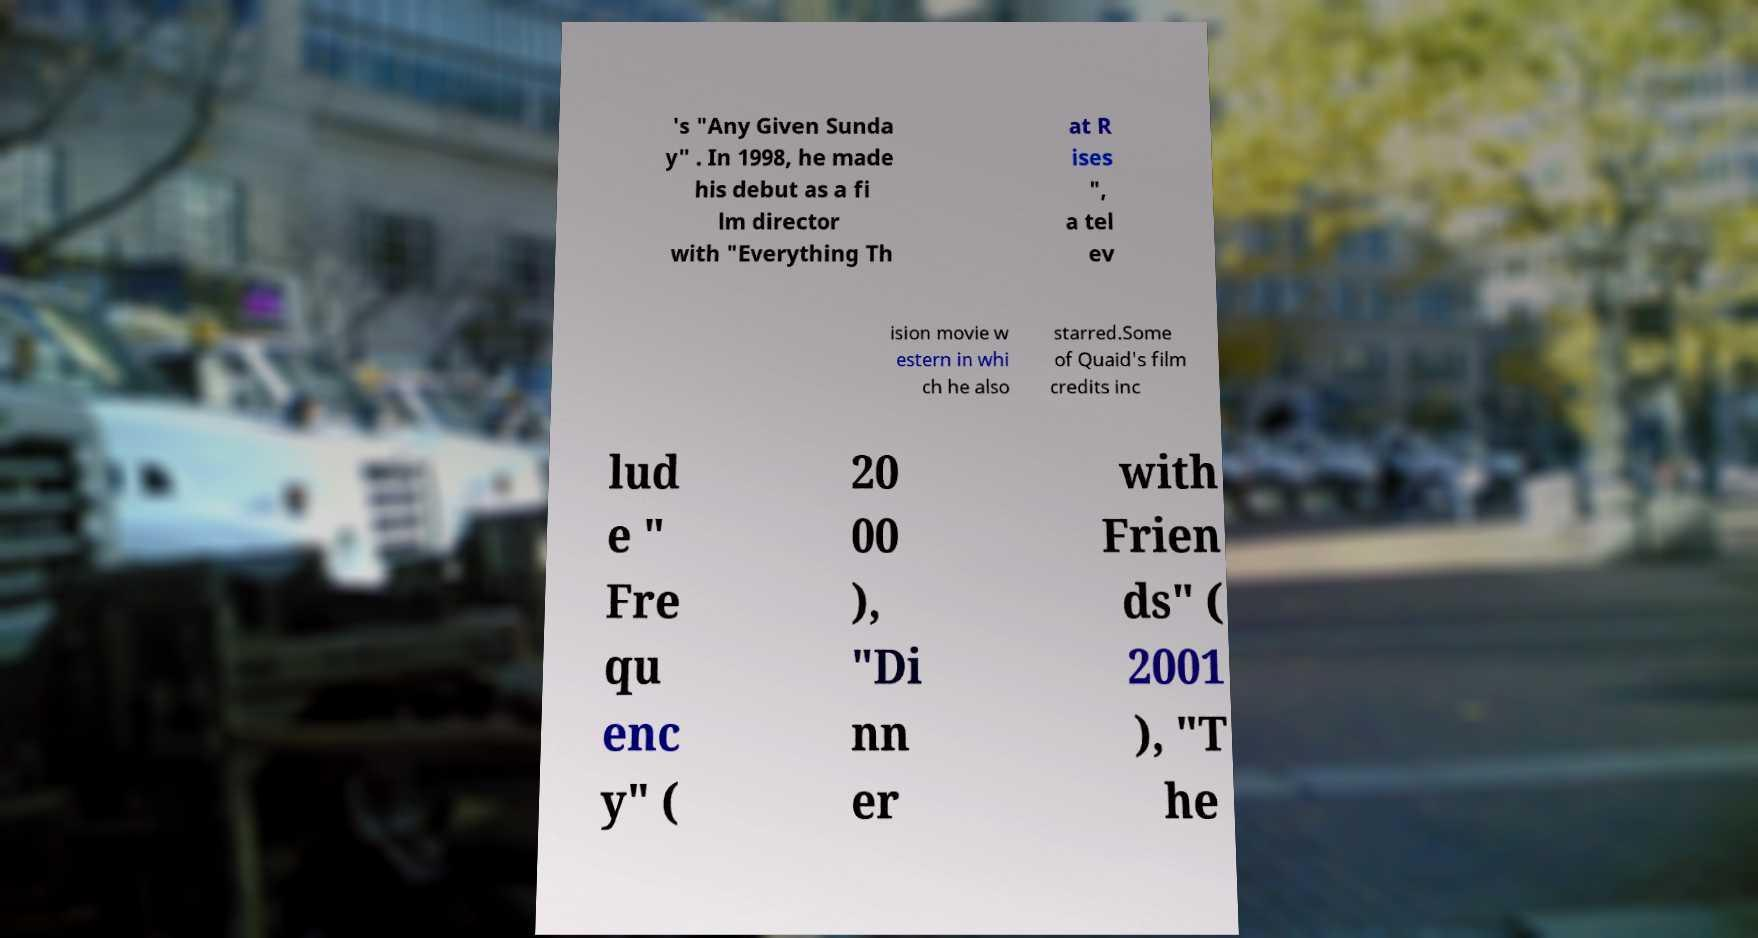Can you read and provide the text displayed in the image?This photo seems to have some interesting text. Can you extract and type it out for me? 's "Any Given Sunda y" . In 1998, he made his debut as a fi lm director with "Everything Th at R ises ", a tel ev ision movie w estern in whi ch he also starred.Some of Quaid's film credits inc lud e " Fre qu enc y" ( 20 00 ), "Di nn er with Frien ds" ( 2001 ), "T he 